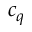Convert formula to latex. <formula><loc_0><loc_0><loc_500><loc_500>c _ { q }</formula> 